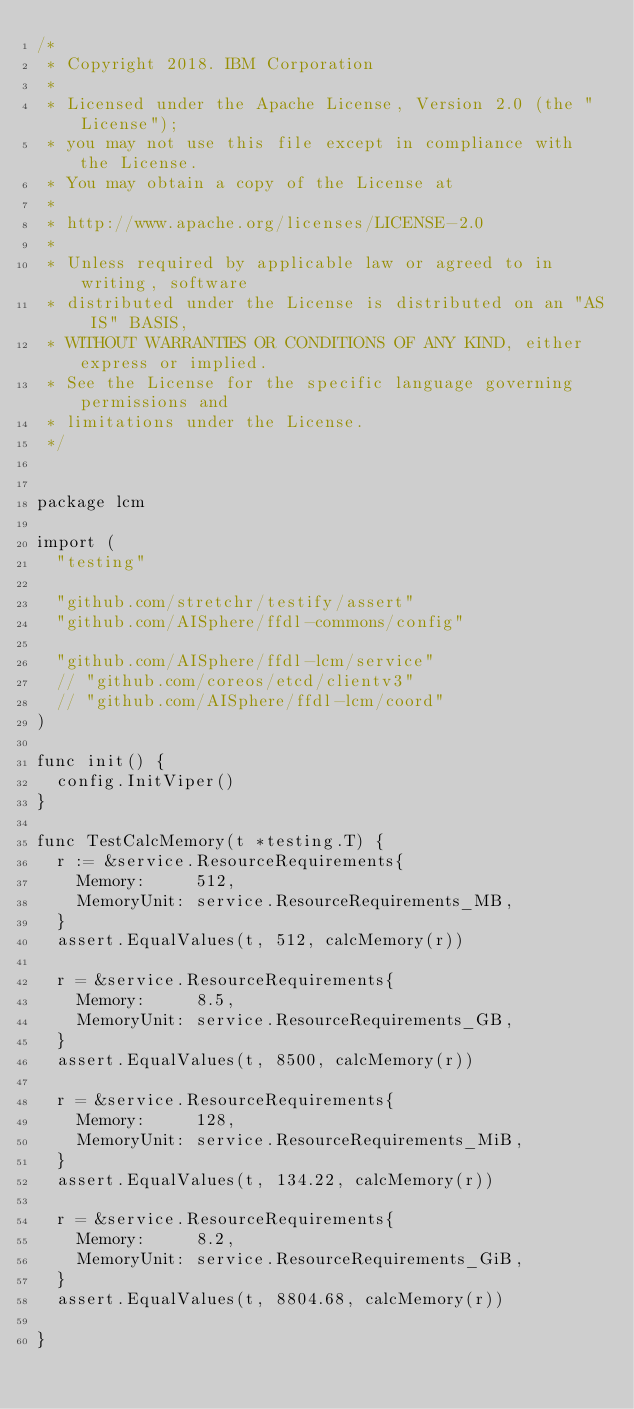Convert code to text. <code><loc_0><loc_0><loc_500><loc_500><_Go_>/*
 * Copyright 2018. IBM Corporation
 *
 * Licensed under the Apache License, Version 2.0 (the "License");
 * you may not use this file except in compliance with the License.
 * You may obtain a copy of the License at
 *
 * http://www.apache.org/licenses/LICENSE-2.0
 *
 * Unless required by applicable law or agreed to in writing, software
 * distributed under the License is distributed on an "AS IS" BASIS,
 * WITHOUT WARRANTIES OR CONDITIONS OF ANY KIND, either express or implied.
 * See the License for the specific language governing permissions and
 * limitations under the License.
 */


package lcm

import (
	"testing"

	"github.com/stretchr/testify/assert"
	"github.com/AISphere/ffdl-commons/config"

	"github.com/AISphere/ffdl-lcm/service"
	// "github.com/coreos/etcd/clientv3"
	// "github.com/AISphere/ffdl-lcm/coord"
)

func init() {
	config.InitViper()
}

func TestCalcMemory(t *testing.T) {
	r := &service.ResourceRequirements{
		Memory:     512,
		MemoryUnit: service.ResourceRequirements_MB,
	}
	assert.EqualValues(t, 512, calcMemory(r))

	r = &service.ResourceRequirements{
		Memory:     8.5,
		MemoryUnit: service.ResourceRequirements_GB,
	}
	assert.EqualValues(t, 8500, calcMemory(r))

	r = &service.ResourceRequirements{
		Memory:     128,
		MemoryUnit: service.ResourceRequirements_MiB,
	}
	assert.EqualValues(t, 134.22, calcMemory(r))

	r = &service.ResourceRequirements{
		Memory:     8.2,
		MemoryUnit: service.ResourceRequirements_GiB,
	}
	assert.EqualValues(t, 8804.68, calcMemory(r))

}
</code> 